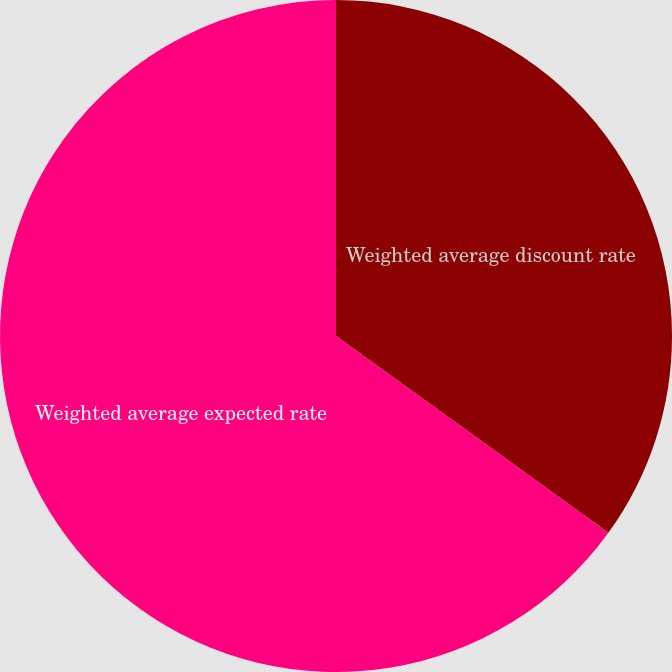Convert chart. <chart><loc_0><loc_0><loc_500><loc_500><pie_chart><fcel>Weighted average discount rate<fcel>Weighted average expected rate<nl><fcel>34.96%<fcel>65.04%<nl></chart> 